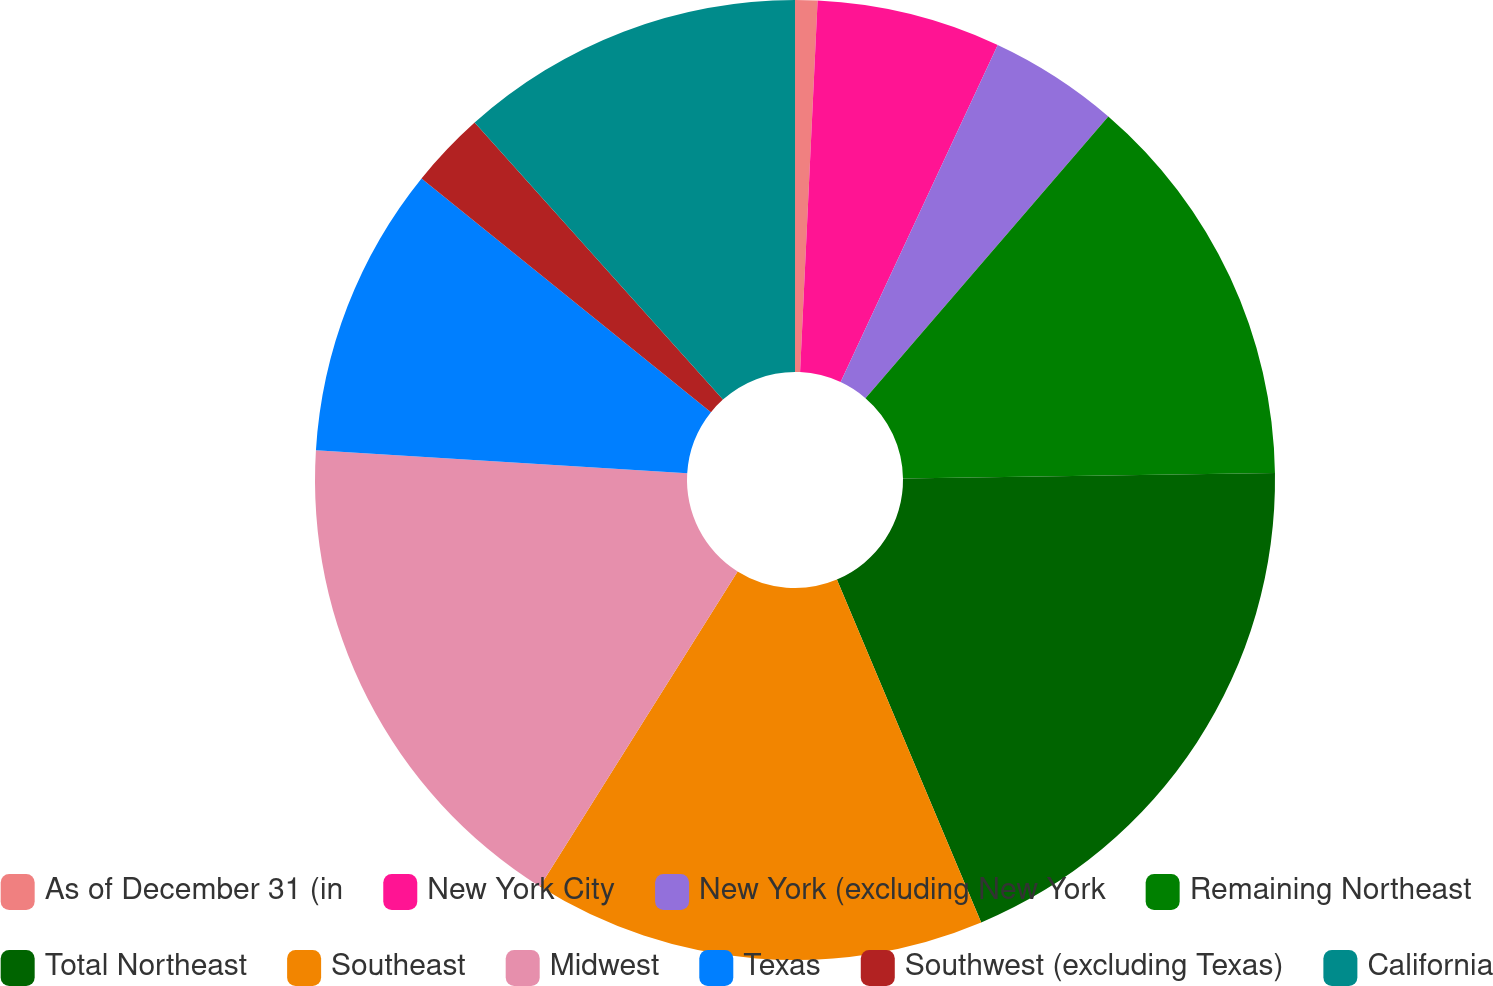<chart> <loc_0><loc_0><loc_500><loc_500><pie_chart><fcel>As of December 31 (in<fcel>New York City<fcel>New York (excluding New York<fcel>Remaining Northeast<fcel>Total Northeast<fcel>Southeast<fcel>Midwest<fcel>Texas<fcel>Southwest (excluding Texas)<fcel>California<nl><fcel>0.75%<fcel>6.19%<fcel>4.38%<fcel>13.45%<fcel>18.89%<fcel>15.26%<fcel>17.07%<fcel>9.82%<fcel>2.56%<fcel>11.63%<nl></chart> 